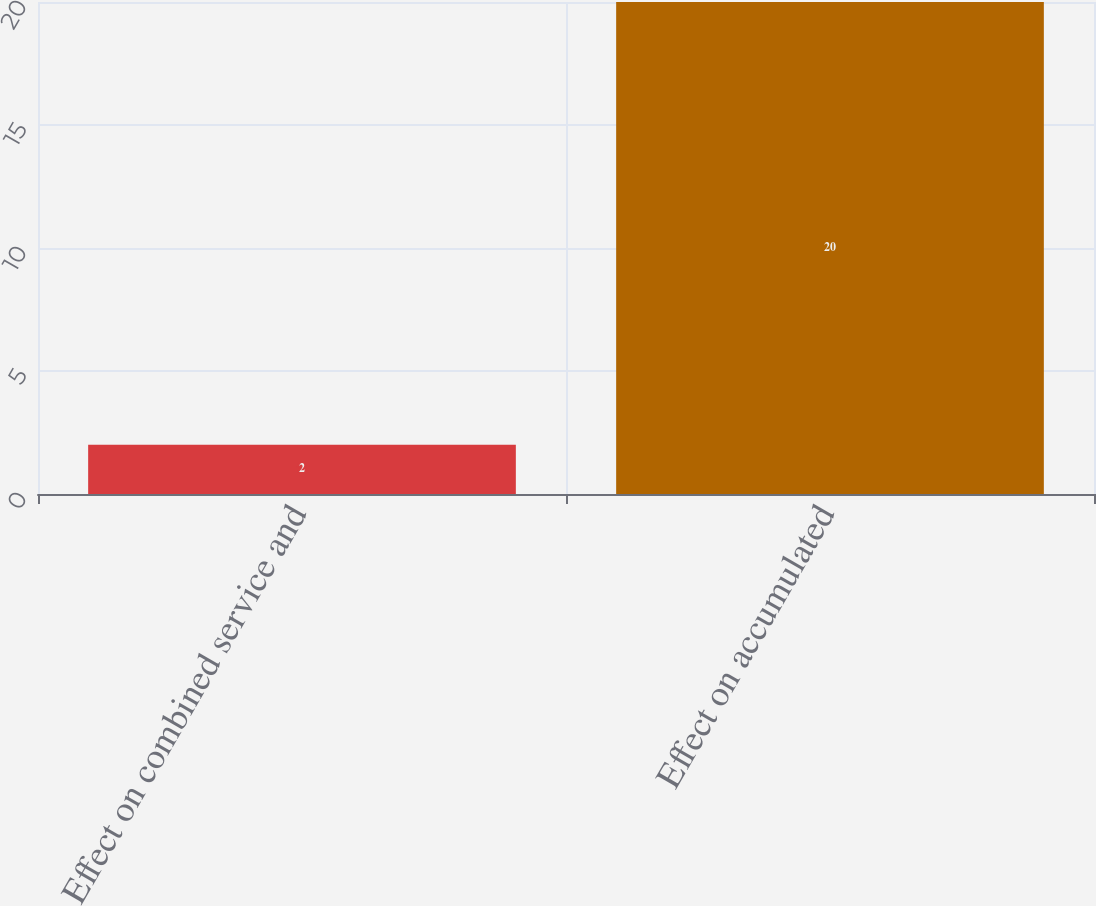<chart> <loc_0><loc_0><loc_500><loc_500><bar_chart><fcel>Effect on combined service and<fcel>Effect on accumulated<nl><fcel>2<fcel>20<nl></chart> 